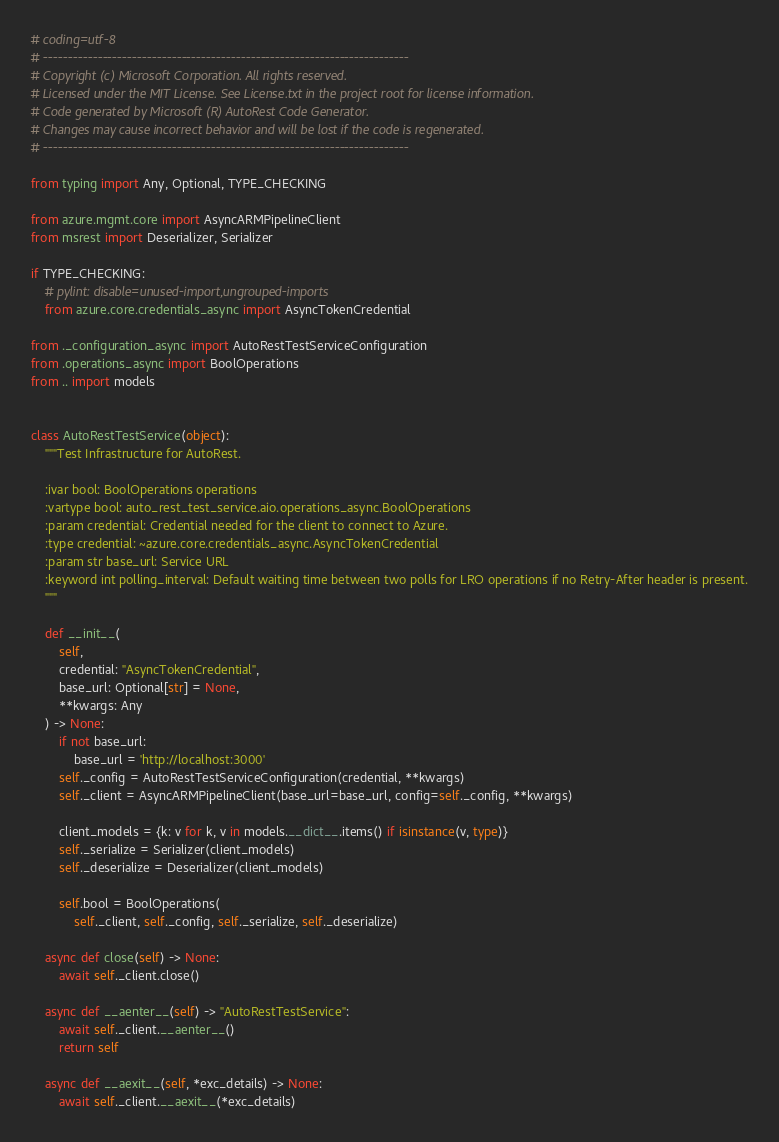Convert code to text. <code><loc_0><loc_0><loc_500><loc_500><_Python_># coding=utf-8
# --------------------------------------------------------------------------
# Copyright (c) Microsoft Corporation. All rights reserved.
# Licensed under the MIT License. See License.txt in the project root for license information.
# Code generated by Microsoft (R) AutoRest Code Generator.
# Changes may cause incorrect behavior and will be lost if the code is regenerated.
# --------------------------------------------------------------------------

from typing import Any, Optional, TYPE_CHECKING

from azure.mgmt.core import AsyncARMPipelineClient
from msrest import Deserializer, Serializer

if TYPE_CHECKING:
    # pylint: disable=unused-import,ungrouped-imports
    from azure.core.credentials_async import AsyncTokenCredential

from ._configuration_async import AutoRestTestServiceConfiguration
from .operations_async import BoolOperations
from .. import models


class AutoRestTestService(object):
    """Test Infrastructure for AutoRest.

    :ivar bool: BoolOperations operations
    :vartype bool: auto_rest_test_service.aio.operations_async.BoolOperations
    :param credential: Credential needed for the client to connect to Azure.
    :type credential: ~azure.core.credentials_async.AsyncTokenCredential
    :param str base_url: Service URL
    :keyword int polling_interval: Default waiting time between two polls for LRO operations if no Retry-After header is present.
    """

    def __init__(
        self,
        credential: "AsyncTokenCredential",
        base_url: Optional[str] = None,
        **kwargs: Any
    ) -> None:
        if not base_url:
            base_url = 'http://localhost:3000'
        self._config = AutoRestTestServiceConfiguration(credential, **kwargs)
        self._client = AsyncARMPipelineClient(base_url=base_url, config=self._config, **kwargs)

        client_models = {k: v for k, v in models.__dict__.items() if isinstance(v, type)}
        self._serialize = Serializer(client_models)
        self._deserialize = Deserializer(client_models)

        self.bool = BoolOperations(
            self._client, self._config, self._serialize, self._deserialize)

    async def close(self) -> None:
        await self._client.close()

    async def __aenter__(self) -> "AutoRestTestService":
        await self._client.__aenter__()
        return self

    async def __aexit__(self, *exc_details) -> None:
        await self._client.__aexit__(*exc_details)
</code> 